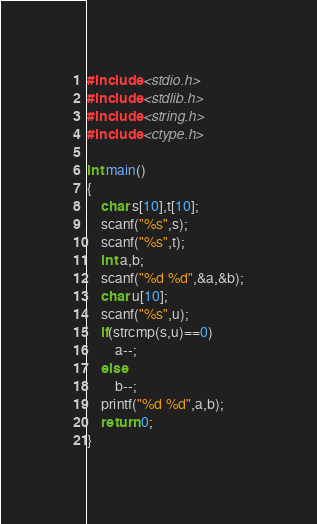Convert code to text. <code><loc_0><loc_0><loc_500><loc_500><_C++_>#include <stdio.h>
#include <stdlib.h>
#include <string.h>
#include <ctype.h>

int main()
{
    char s[10],t[10];
    scanf("%s",s);
    scanf("%s",t);
    int a,b;
    scanf("%d %d",&a,&b);
    char u[10];
    scanf("%s",u);
    if(strcmp(s,u)==0)
        a--;
    else
        b--;
    printf("%d %d",a,b);
    return 0;
}
</code> 